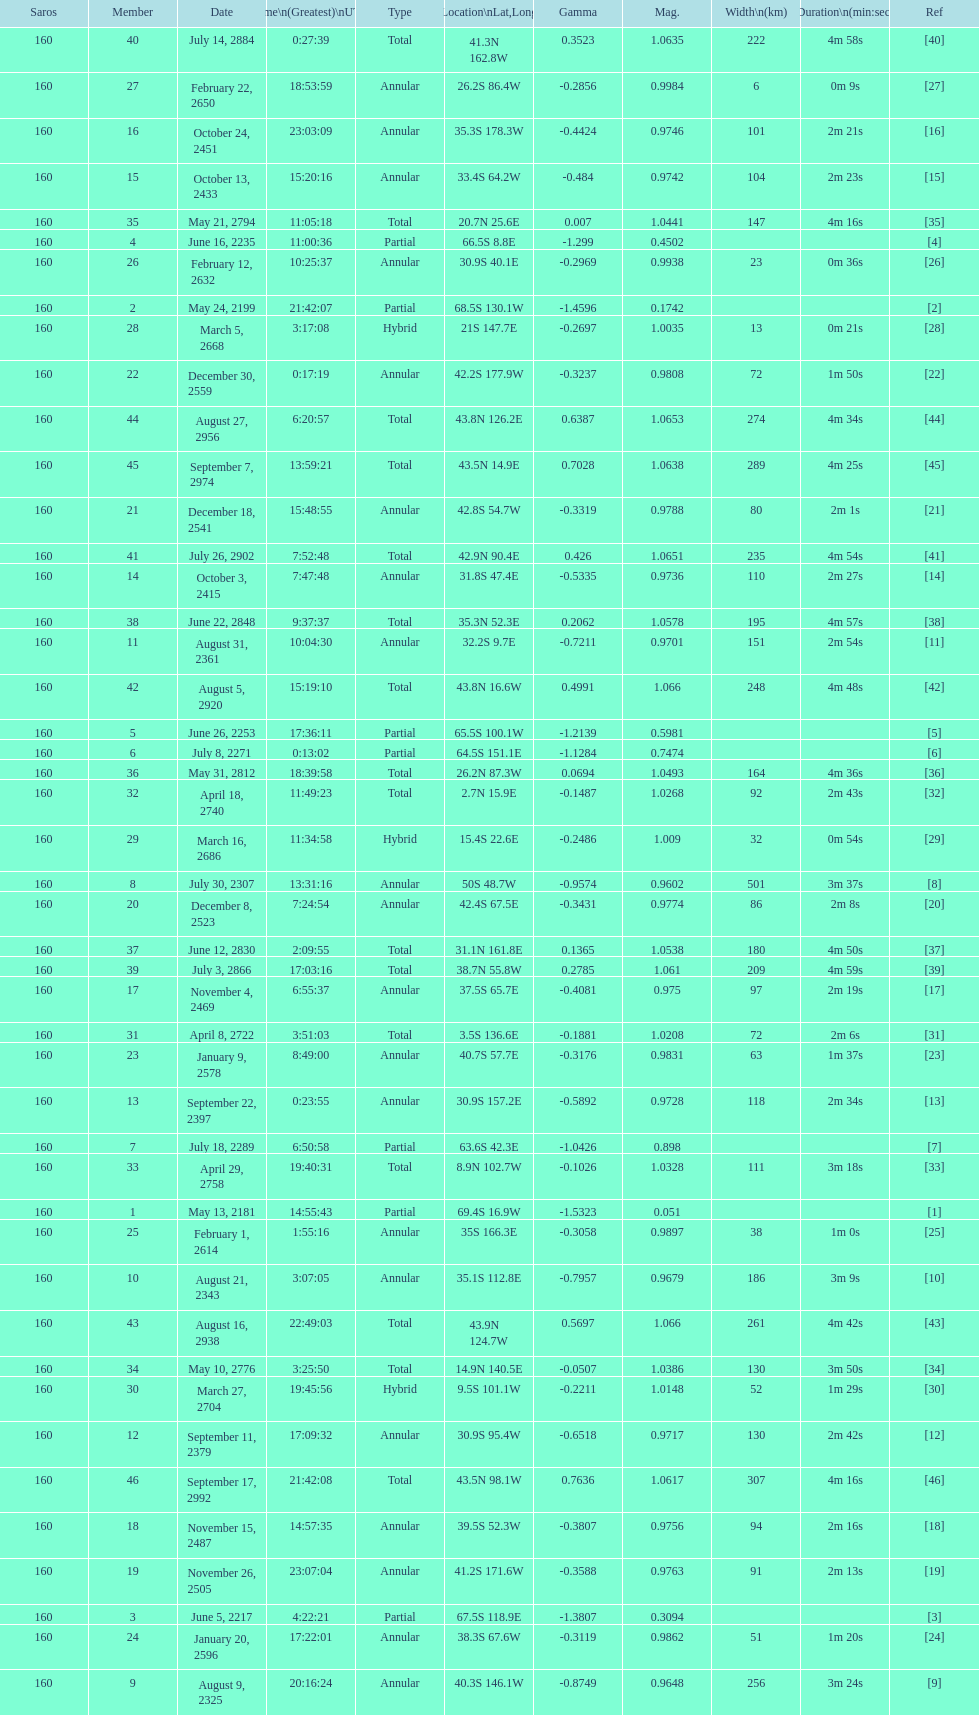How long did 18 last? 2m 16s. 